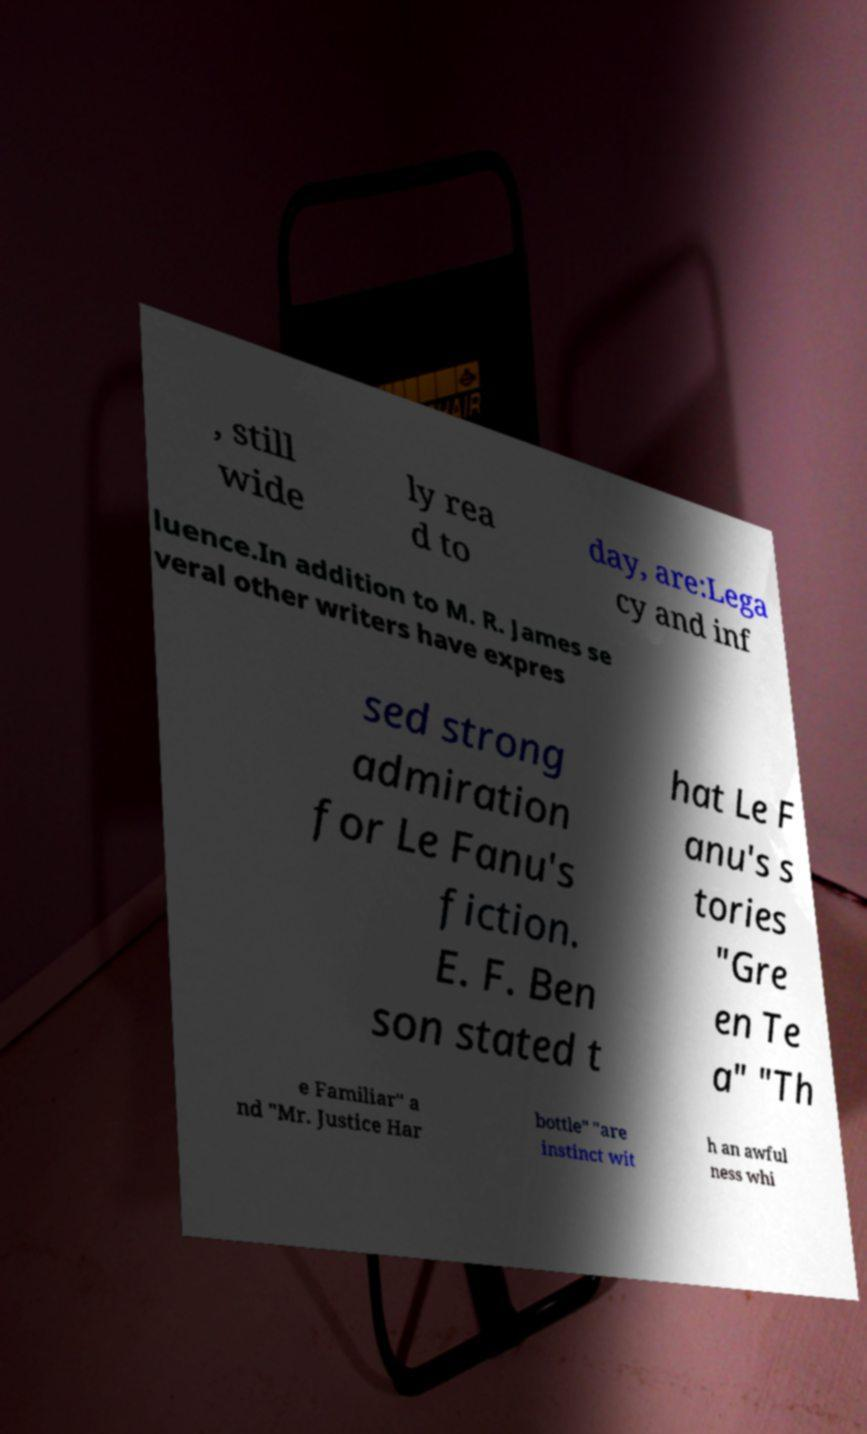Can you accurately transcribe the text from the provided image for me? , still wide ly rea d to day, are:Lega cy and inf luence.In addition to M. R. James se veral other writers have expres sed strong admiration for Le Fanu's fiction. E. F. Ben son stated t hat Le F anu's s tories "Gre en Te a" "Th e Familiar" a nd "Mr. Justice Har bottle" "are instinct wit h an awful ness whi 